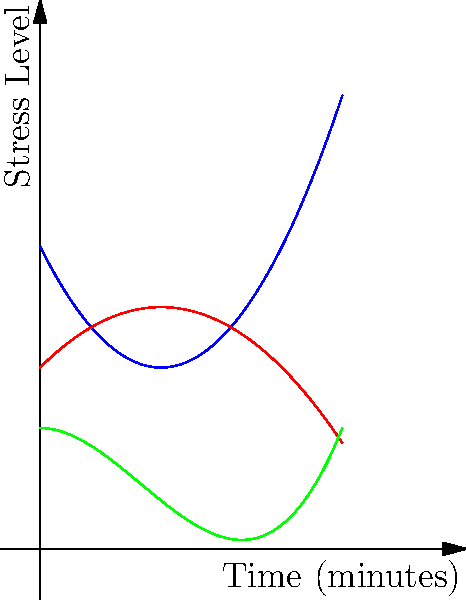A therapist is comparing three relaxation techniques for managing wedding-related stress. The graph shows the stress levels of clients over time for each technique. Which technique is most effective in reducing stress after 5 minutes of practice? To determine the most effective technique after 5 minutes, we need to compare the stress levels at x = 5 for each curve:

1. Technique A (blue curve): $f_1(x) = 0.5x^2 - 2x + 5$
   At x = 5: $f_1(5) = 0.5(5)^2 - 2(5) + 5 = 12.5 - 10 + 5 = 7.5$

2. Technique B (red curve): $f_2(x) = -0.25x^2 + x + 3$
   At x = 5: $f_2(5) = -0.25(5)^2 + 5 + 3 = -6.25 + 8 = 1.75$

3. Technique C (green curve): $f_3(x) = 0.1x^3 - 0.5x^2 + 2$
   At x = 5: $f_3(5) = 0.1(5)^3 - 0.5(5)^2 + 2 = 12.5 - 12.5 + 2 = 2$

Comparing these values, we see that Technique B has the lowest stress level (1.75) after 5 minutes, making it the most effective in reducing stress.
Answer: Technique B 